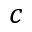<formula> <loc_0><loc_0><loc_500><loc_500>c</formula> 